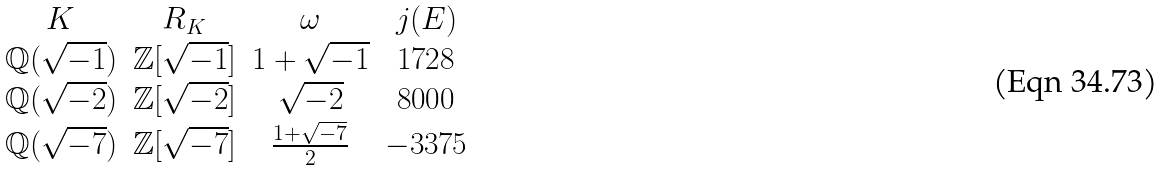<formula> <loc_0><loc_0><loc_500><loc_500>\begin{array} { c c c c } K & R _ { K } & \omega & j ( E ) \\ \mathbb { Q } ( \sqrt { - 1 } ) & \mathbb { Z } [ \sqrt { - 1 } ] & 1 + \sqrt { - 1 } & 1 7 2 8 \\ \mathbb { Q } ( \sqrt { - 2 } ) & \mathbb { Z } [ \sqrt { - 2 } ] & \sqrt { - 2 } & 8 0 0 0 \\ \mathbb { Q } ( \sqrt { - 7 } ) & \mathbb { Z } [ \sqrt { - 7 } ] & \frac { 1 + \sqrt { - 7 } } { 2 } & - 3 3 7 5 \end{array}</formula> 